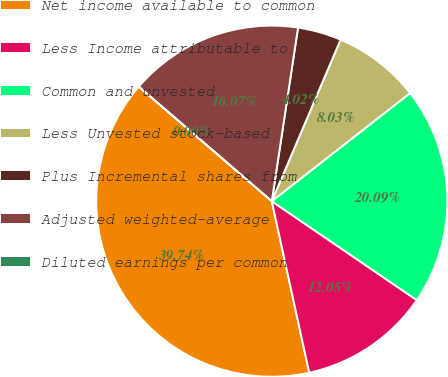Convert chart to OTSL. <chart><loc_0><loc_0><loc_500><loc_500><pie_chart><fcel>Net income available to common<fcel>Less Income attributable to<fcel>Common and unvested<fcel>Less Unvested stock-based<fcel>Plus Incremental shares from<fcel>Adjusted weighted-average<fcel>Diluted earnings per common<nl><fcel>39.74%<fcel>12.05%<fcel>20.09%<fcel>8.03%<fcel>4.02%<fcel>16.07%<fcel>0.0%<nl></chart> 